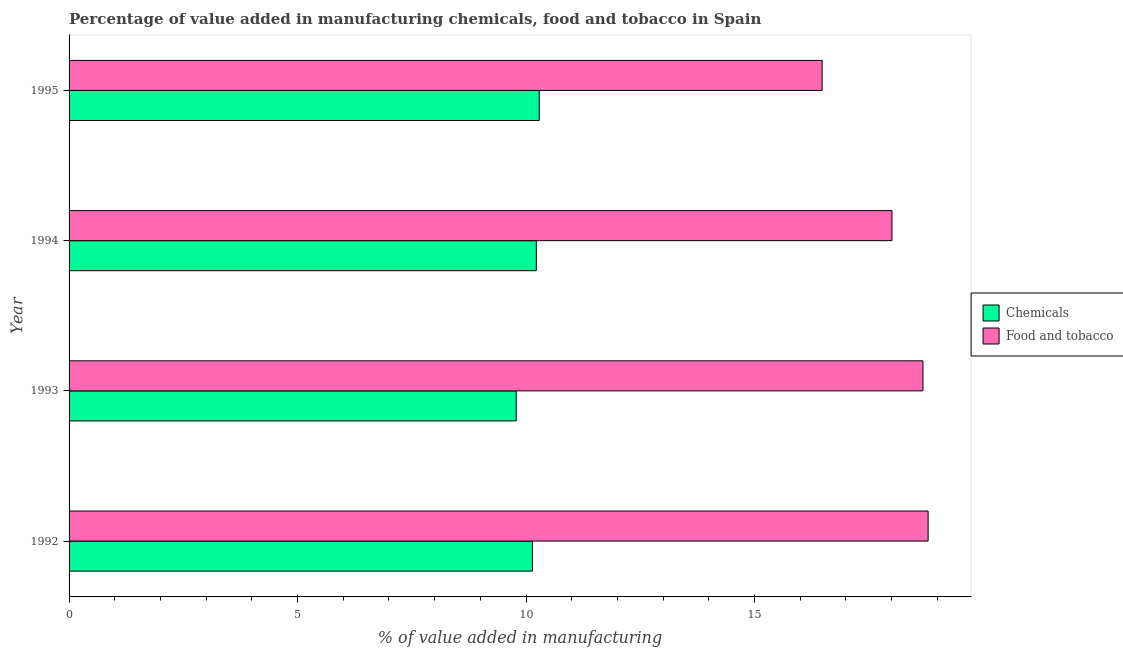How many different coloured bars are there?
Your answer should be compact. 2. How many groups of bars are there?
Your answer should be compact. 4. Are the number of bars on each tick of the Y-axis equal?
Your answer should be compact. Yes. How many bars are there on the 2nd tick from the top?
Give a very brief answer. 2. How many bars are there on the 2nd tick from the bottom?
Your answer should be very brief. 2. What is the value added by  manufacturing chemicals in 1993?
Keep it short and to the point. 9.78. Across all years, what is the maximum value added by  manufacturing chemicals?
Your answer should be compact. 10.29. Across all years, what is the minimum value added by  manufacturing chemicals?
Provide a succinct answer. 9.78. In which year was the value added by  manufacturing chemicals maximum?
Give a very brief answer. 1995. What is the total value added by manufacturing food and tobacco in the graph?
Provide a short and direct response. 71.97. What is the difference between the value added by  manufacturing chemicals in 1992 and that in 1994?
Your answer should be compact. -0.09. What is the difference between the value added by  manufacturing chemicals in 1995 and the value added by manufacturing food and tobacco in 1994?
Your answer should be very brief. -7.72. What is the average value added by  manufacturing chemicals per year?
Give a very brief answer. 10.11. In the year 1995, what is the difference between the value added by manufacturing food and tobacco and value added by  manufacturing chemicals?
Your answer should be very brief. 6.19. What is the ratio of the value added by  manufacturing chemicals in 1993 to that in 1995?
Provide a short and direct response. 0.95. Is the difference between the value added by manufacturing food and tobacco in 1993 and 1994 greater than the difference between the value added by  manufacturing chemicals in 1993 and 1994?
Give a very brief answer. Yes. What is the difference between the highest and the second highest value added by  manufacturing chemicals?
Your answer should be very brief. 0.06. What is the difference between the highest and the lowest value added by manufacturing food and tobacco?
Give a very brief answer. 2.32. What does the 1st bar from the top in 1992 represents?
Offer a very short reply. Food and tobacco. What does the 1st bar from the bottom in 1993 represents?
Provide a short and direct response. Chemicals. How many bars are there?
Your answer should be very brief. 8. What is the difference between two consecutive major ticks on the X-axis?
Offer a terse response. 5. Does the graph contain grids?
Provide a short and direct response. No. How are the legend labels stacked?
Your response must be concise. Vertical. What is the title of the graph?
Make the answer very short. Percentage of value added in manufacturing chemicals, food and tobacco in Spain. What is the label or title of the X-axis?
Provide a short and direct response. % of value added in manufacturing. What is the % of value added in manufacturing of Chemicals in 1992?
Offer a very short reply. 10.14. What is the % of value added in manufacturing in Food and tobacco in 1992?
Your answer should be very brief. 18.8. What is the % of value added in manufacturing in Chemicals in 1993?
Offer a very short reply. 9.78. What is the % of value added in manufacturing in Food and tobacco in 1993?
Provide a succinct answer. 18.69. What is the % of value added in manufacturing of Chemicals in 1994?
Your response must be concise. 10.23. What is the % of value added in manufacturing in Food and tobacco in 1994?
Give a very brief answer. 18.01. What is the % of value added in manufacturing of Chemicals in 1995?
Provide a short and direct response. 10.29. What is the % of value added in manufacturing in Food and tobacco in 1995?
Keep it short and to the point. 16.48. Across all years, what is the maximum % of value added in manufacturing of Chemicals?
Provide a short and direct response. 10.29. Across all years, what is the maximum % of value added in manufacturing of Food and tobacco?
Ensure brevity in your answer.  18.8. Across all years, what is the minimum % of value added in manufacturing of Chemicals?
Offer a terse response. 9.78. Across all years, what is the minimum % of value added in manufacturing of Food and tobacco?
Ensure brevity in your answer.  16.48. What is the total % of value added in manufacturing in Chemicals in the graph?
Offer a terse response. 40.44. What is the total % of value added in manufacturing of Food and tobacco in the graph?
Your answer should be very brief. 71.97. What is the difference between the % of value added in manufacturing in Chemicals in 1992 and that in 1993?
Make the answer very short. 0.35. What is the difference between the % of value added in manufacturing of Food and tobacco in 1992 and that in 1993?
Your answer should be very brief. 0.11. What is the difference between the % of value added in manufacturing of Chemicals in 1992 and that in 1994?
Make the answer very short. -0.09. What is the difference between the % of value added in manufacturing of Food and tobacco in 1992 and that in 1994?
Provide a succinct answer. 0.79. What is the difference between the % of value added in manufacturing of Chemicals in 1992 and that in 1995?
Offer a very short reply. -0.15. What is the difference between the % of value added in manufacturing in Food and tobacco in 1992 and that in 1995?
Your answer should be very brief. 2.32. What is the difference between the % of value added in manufacturing of Chemicals in 1993 and that in 1994?
Give a very brief answer. -0.44. What is the difference between the % of value added in manufacturing of Food and tobacco in 1993 and that in 1994?
Give a very brief answer. 0.68. What is the difference between the % of value added in manufacturing in Chemicals in 1993 and that in 1995?
Provide a short and direct response. -0.5. What is the difference between the % of value added in manufacturing in Food and tobacco in 1993 and that in 1995?
Your response must be concise. 2.21. What is the difference between the % of value added in manufacturing in Chemicals in 1994 and that in 1995?
Provide a short and direct response. -0.06. What is the difference between the % of value added in manufacturing of Food and tobacco in 1994 and that in 1995?
Give a very brief answer. 1.53. What is the difference between the % of value added in manufacturing of Chemicals in 1992 and the % of value added in manufacturing of Food and tobacco in 1993?
Offer a very short reply. -8.55. What is the difference between the % of value added in manufacturing of Chemicals in 1992 and the % of value added in manufacturing of Food and tobacco in 1994?
Keep it short and to the point. -7.87. What is the difference between the % of value added in manufacturing in Chemicals in 1992 and the % of value added in manufacturing in Food and tobacco in 1995?
Offer a very short reply. -6.34. What is the difference between the % of value added in manufacturing in Chemicals in 1993 and the % of value added in manufacturing in Food and tobacco in 1994?
Provide a short and direct response. -8.22. What is the difference between the % of value added in manufacturing of Chemicals in 1993 and the % of value added in manufacturing of Food and tobacco in 1995?
Provide a succinct answer. -6.7. What is the difference between the % of value added in manufacturing in Chemicals in 1994 and the % of value added in manufacturing in Food and tobacco in 1995?
Offer a very short reply. -6.25. What is the average % of value added in manufacturing of Chemicals per year?
Provide a succinct answer. 10.11. What is the average % of value added in manufacturing in Food and tobacco per year?
Ensure brevity in your answer.  17.99. In the year 1992, what is the difference between the % of value added in manufacturing in Chemicals and % of value added in manufacturing in Food and tobacco?
Offer a very short reply. -8.66. In the year 1993, what is the difference between the % of value added in manufacturing of Chemicals and % of value added in manufacturing of Food and tobacco?
Offer a terse response. -8.9. In the year 1994, what is the difference between the % of value added in manufacturing in Chemicals and % of value added in manufacturing in Food and tobacco?
Make the answer very short. -7.78. In the year 1995, what is the difference between the % of value added in manufacturing of Chemicals and % of value added in manufacturing of Food and tobacco?
Your answer should be very brief. -6.19. What is the ratio of the % of value added in manufacturing of Chemicals in 1992 to that in 1993?
Ensure brevity in your answer.  1.04. What is the ratio of the % of value added in manufacturing in Food and tobacco in 1992 to that in 1994?
Keep it short and to the point. 1.04. What is the ratio of the % of value added in manufacturing of Chemicals in 1992 to that in 1995?
Offer a terse response. 0.99. What is the ratio of the % of value added in manufacturing in Food and tobacco in 1992 to that in 1995?
Your answer should be compact. 1.14. What is the ratio of the % of value added in manufacturing of Chemicals in 1993 to that in 1994?
Keep it short and to the point. 0.96. What is the ratio of the % of value added in manufacturing of Food and tobacco in 1993 to that in 1994?
Ensure brevity in your answer.  1.04. What is the ratio of the % of value added in manufacturing of Chemicals in 1993 to that in 1995?
Give a very brief answer. 0.95. What is the ratio of the % of value added in manufacturing in Food and tobacco in 1993 to that in 1995?
Your response must be concise. 1.13. What is the ratio of the % of value added in manufacturing of Food and tobacco in 1994 to that in 1995?
Make the answer very short. 1.09. What is the difference between the highest and the second highest % of value added in manufacturing of Chemicals?
Keep it short and to the point. 0.06. What is the difference between the highest and the second highest % of value added in manufacturing of Food and tobacco?
Give a very brief answer. 0.11. What is the difference between the highest and the lowest % of value added in manufacturing of Chemicals?
Give a very brief answer. 0.5. What is the difference between the highest and the lowest % of value added in manufacturing in Food and tobacco?
Ensure brevity in your answer.  2.32. 